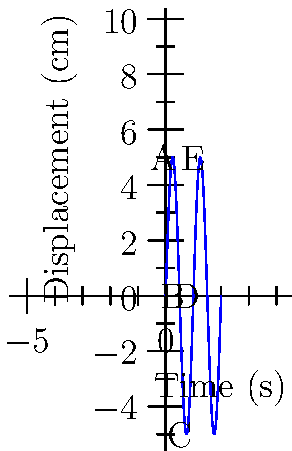Analyze the displacement-time graph of a simple harmonic pendulum motion shown above. The graph depicts a complete cycle of the pendulum's oscillation. Identify the point(s) where the pendulum experiences maximum acceleration. Justify your answer using appropriate physical principles and mathematical relationships. To identify the point(s) of maximum acceleration, we need to consider the following principles:

1. In simple harmonic motion, acceleration is proportional to displacement but in the opposite direction.

2. Mathematically, this is expressed as $a = -\omega^2 x$, where $a$ is acceleration, $\omega$ is angular frequency, and $x$ is displacement.

3. The magnitude of acceleration is maximum when the magnitude of displacement is maximum.

4. From the graph, we can observe that the maximum displacement occurs at points A, C, and E.

5. At point A (0, 5 cm) and E (1 s, 5 cm), the pendulum is at its maximum positive displacement.

6. At point C (0.5 s, -5 cm), the pendulum is at its maximum negative displacement.

7. The acceleration at A and E will be maximum in the negative direction (towards the equilibrium position).

8. The acceleration at C will be maximum in the positive direction (towards the equilibrium position).

9. At points B (0.25 s, 0 cm) and D (0.75 s, 0 cm), the displacement is zero, so the acceleration is also zero.

Therefore, the pendulum experiences maximum acceleration at points A, C, and E.
Answer: Points A, C, and E 